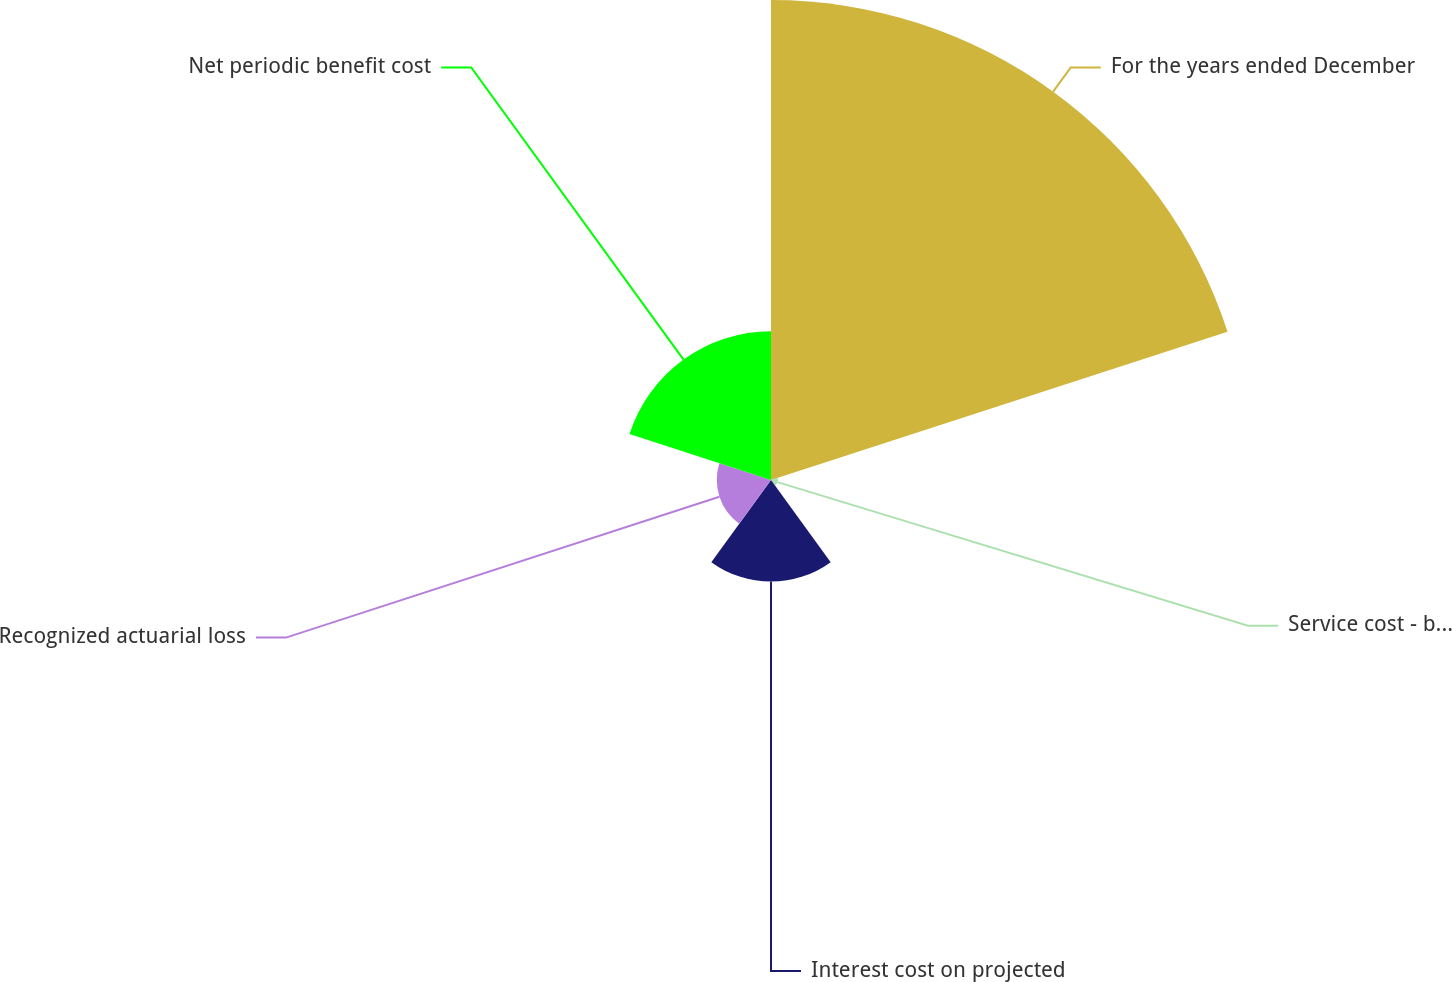<chart> <loc_0><loc_0><loc_500><loc_500><pie_chart><fcel>For the years ended December<fcel>Service cost - benefits earned<fcel>Interest cost on projected<fcel>Recognized actuarial loss<fcel>Net periodic benefit cost<nl><fcel>60.64%<fcel>0.87%<fcel>12.83%<fcel>6.85%<fcel>18.8%<nl></chart> 